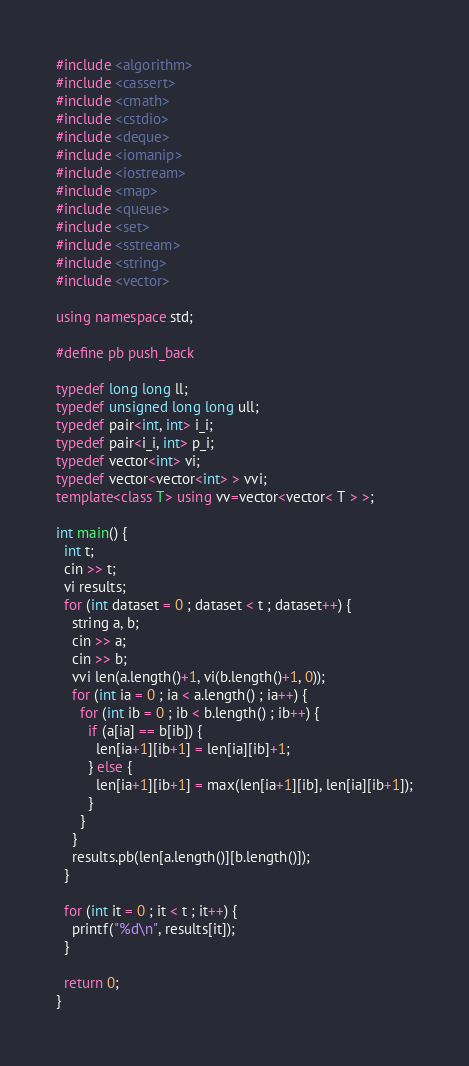Convert code to text. <code><loc_0><loc_0><loc_500><loc_500><_C++_>#include <algorithm>
#include <cassert>
#include <cmath>
#include <cstdio>
#include <deque>
#include <iomanip>
#include <iostream>
#include <map>
#include <queue>
#include <set>
#include <sstream>
#include <string>
#include <vector>

using namespace std;

#define pb push_back

typedef long long ll;
typedef unsigned long long ull;
typedef pair<int, int> i_i;
typedef pair<i_i, int> p_i;
typedef vector<int> vi;
typedef vector<vector<int> > vvi;
template<class T> using vv=vector<vector< T > >;

int main() {
  int t;
  cin >> t;
  vi results;
  for (int dataset = 0 ; dataset < t ; dataset++) {
    string a, b;
    cin >> a;
    cin >> b;
    vvi len(a.length()+1, vi(b.length()+1, 0));
    for (int ia = 0 ; ia < a.length() ; ia++) {
      for (int ib = 0 ; ib < b.length() ; ib++) {
        if (a[ia] == b[ib]) {
          len[ia+1][ib+1] = len[ia][ib]+1;
        } else {
          len[ia+1][ib+1] = max(len[ia+1][ib], len[ia][ib+1]);
        }
      }
    }
    results.pb(len[a.length()][b.length()]);
  }

  for (int it = 0 ; it < t ; it++) {
    printf("%d\n", results[it]);
  }

  return 0;
}</code> 